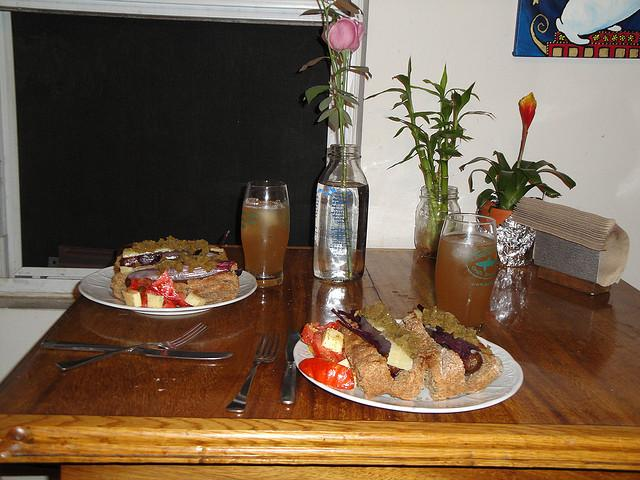What are the items in the brown and grey receptacle for? Please explain your reasoning. wiping. The items are for wiping. 